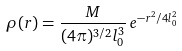<formula> <loc_0><loc_0><loc_500><loc_500>\rho ( r ) = \frac { M } { ( 4 \pi ) ^ { 3 / 2 } l _ { 0 } ^ { 3 } } \, e ^ { - r ^ { 2 } / 4 l _ { 0 } ^ { 2 } }</formula> 